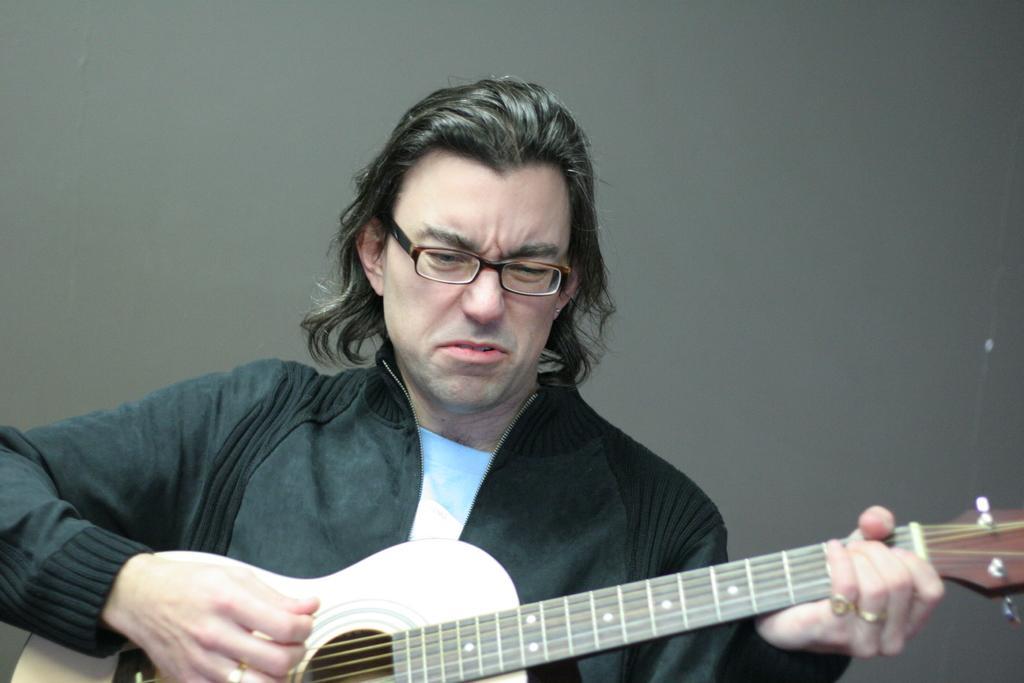Please provide a concise description of this image. As we can see in the image there is a man holding guitar. 